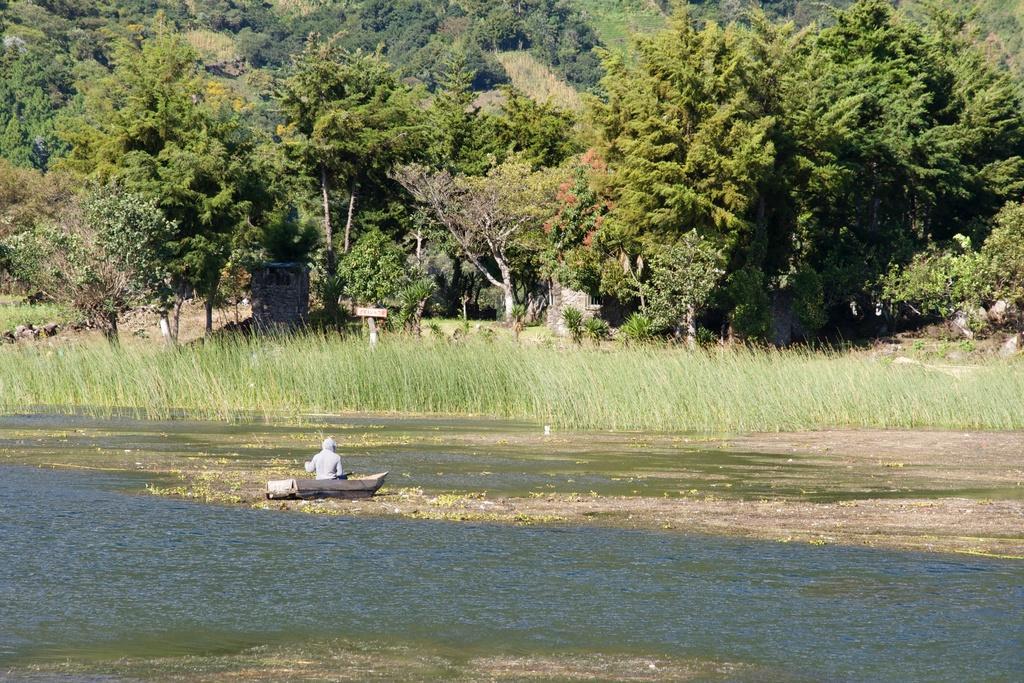How would you summarize this image in a sentence or two? In this image we can see a boat, and a person sitting in it, here is the water, here is the grass, here are the trees, 